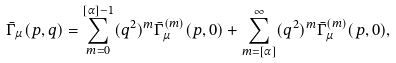<formula> <loc_0><loc_0><loc_500><loc_500>\bar { \Gamma } _ { \mu } ( p , q ) = \sum _ { m = 0 } ^ { [ \alpha ] - 1 } ( q ^ { 2 } ) ^ { m } \bar { \Gamma } _ { \mu } ^ { ( m ) } ( p , 0 ) + \sum _ { m = [ \alpha ] } ^ { \infty } ( q ^ { 2 } ) ^ { m } \bar { \Gamma } _ { \mu } ^ { ( m ) } ( p , 0 ) ,</formula> 